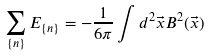<formula> <loc_0><loc_0><loc_500><loc_500>\sum _ { \{ n \} } E _ { \{ n \} } = - \frac { 1 } { 6 \pi } \int d ^ { 2 } \vec { x } B ^ { 2 } ( \vec { x } )</formula> 